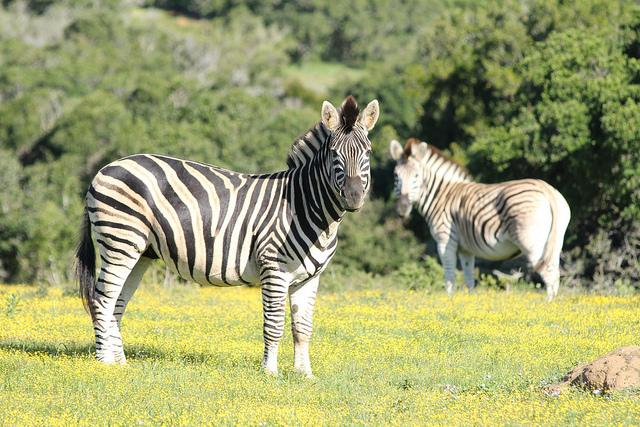Do you think these zebras are friendly?
Short answer required. Yes. Do the zebras look coordinated?
Answer briefly. Yes. Are the zebras close to each other?
Keep it brief. No. Do these zebras like each other?
Write a very short answer. No. How many zebras are visible?
Keep it brief. 2. Is this picture from a zoo?
Give a very brief answer. No. 